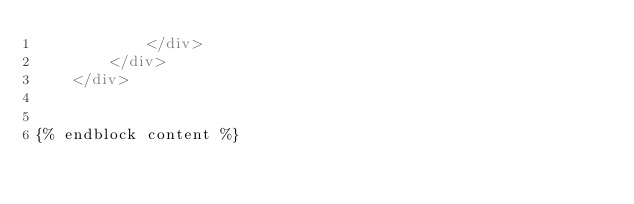<code> <loc_0><loc_0><loc_500><loc_500><_HTML_>            </div>
        </div>
    </div>


{% endblock content %}
</code> 